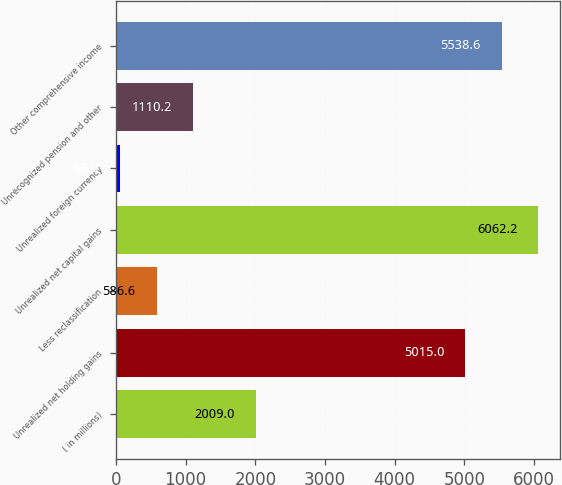Convert chart to OTSL. <chart><loc_0><loc_0><loc_500><loc_500><bar_chart><fcel>( in millions)<fcel>Unrealized net holding gains<fcel>Less reclassification<fcel>Unrealized net capital gains<fcel>Unrealized foreign currency<fcel>Unrecognized pension and other<fcel>Other comprehensive income<nl><fcel>2009<fcel>5015<fcel>586.6<fcel>6062.2<fcel>63<fcel>1110.2<fcel>5538.6<nl></chart> 